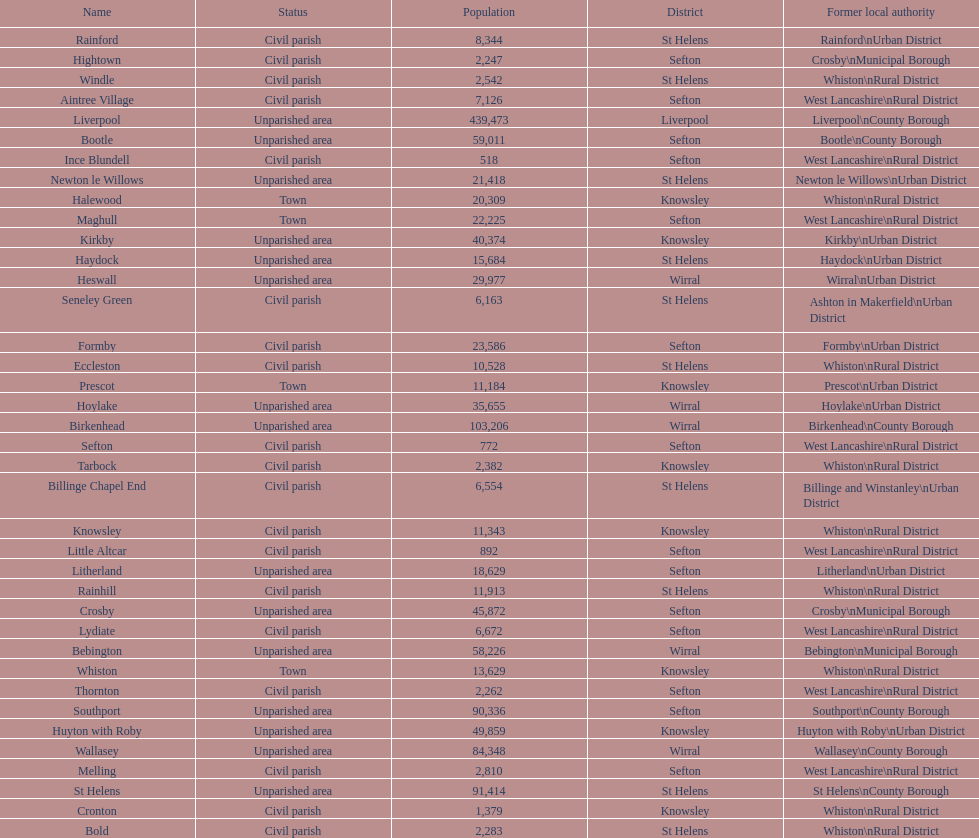Which area has the least number of residents? Ince Blundell. Would you be able to parse every entry in this table? {'header': ['Name', 'Status', 'Population', 'District', 'Former local authority'], 'rows': [['Rainford', 'Civil parish', '8,344', 'St Helens', 'Rainford\\nUrban District'], ['Hightown', 'Civil parish', '2,247', 'Sefton', 'Crosby\\nMunicipal Borough'], ['Windle', 'Civil parish', '2,542', 'St Helens', 'Whiston\\nRural District'], ['Aintree Village', 'Civil parish', '7,126', 'Sefton', 'West Lancashire\\nRural District'], ['Liverpool', 'Unparished area', '439,473', 'Liverpool', 'Liverpool\\nCounty Borough'], ['Bootle', 'Unparished area', '59,011', 'Sefton', 'Bootle\\nCounty Borough'], ['Ince Blundell', 'Civil parish', '518', 'Sefton', 'West Lancashire\\nRural District'], ['Newton le Willows', 'Unparished area', '21,418', 'St Helens', 'Newton le Willows\\nUrban District'], ['Halewood', 'Town', '20,309', 'Knowsley', 'Whiston\\nRural District'], ['Maghull', 'Town', '22,225', 'Sefton', 'West Lancashire\\nRural District'], ['Kirkby', 'Unparished area', '40,374', 'Knowsley', 'Kirkby\\nUrban District'], ['Haydock', 'Unparished area', '15,684', 'St Helens', 'Haydock\\nUrban District'], ['Heswall', 'Unparished area', '29,977', 'Wirral', 'Wirral\\nUrban District'], ['Seneley Green', 'Civil parish', '6,163', 'St Helens', 'Ashton in Makerfield\\nUrban District'], ['Formby', 'Civil parish', '23,586', 'Sefton', 'Formby\\nUrban District'], ['Eccleston', 'Civil parish', '10,528', 'St Helens', 'Whiston\\nRural District'], ['Prescot', 'Town', '11,184', 'Knowsley', 'Prescot\\nUrban District'], ['Hoylake', 'Unparished area', '35,655', 'Wirral', 'Hoylake\\nUrban District'], ['Birkenhead', 'Unparished area', '103,206', 'Wirral', 'Birkenhead\\nCounty Borough'], ['Sefton', 'Civil parish', '772', 'Sefton', 'West Lancashire\\nRural District'], ['Tarbock', 'Civil parish', '2,382', 'Knowsley', 'Whiston\\nRural District'], ['Billinge Chapel End', 'Civil parish', '6,554', 'St Helens', 'Billinge and Winstanley\\nUrban District'], ['Knowsley', 'Civil parish', '11,343', 'Knowsley', 'Whiston\\nRural District'], ['Little Altcar', 'Civil parish', '892', 'Sefton', 'West Lancashire\\nRural District'], ['Litherland', 'Unparished area', '18,629', 'Sefton', 'Litherland\\nUrban District'], ['Rainhill', 'Civil parish', '11,913', 'St Helens', 'Whiston\\nRural District'], ['Crosby', 'Unparished area', '45,872', 'Sefton', 'Crosby\\nMunicipal Borough'], ['Lydiate', 'Civil parish', '6,672', 'Sefton', 'West Lancashire\\nRural District'], ['Bebington', 'Unparished area', '58,226', 'Wirral', 'Bebington\\nMunicipal Borough'], ['Whiston', 'Town', '13,629', 'Knowsley', 'Whiston\\nRural District'], ['Thornton', 'Civil parish', '2,262', 'Sefton', 'West Lancashire\\nRural District'], ['Southport', 'Unparished area', '90,336', 'Sefton', 'Southport\\nCounty Borough'], ['Huyton with Roby', 'Unparished area', '49,859', 'Knowsley', 'Huyton with Roby\\nUrban District'], ['Wallasey', 'Unparished area', '84,348', 'Wirral', 'Wallasey\\nCounty Borough'], ['Melling', 'Civil parish', '2,810', 'Sefton', 'West Lancashire\\nRural District'], ['St Helens', 'Unparished area', '91,414', 'St Helens', 'St Helens\\nCounty Borough'], ['Cronton', 'Civil parish', '1,379', 'Knowsley', 'Whiston\\nRural District'], ['Bold', 'Civil parish', '2,283', 'St Helens', 'Whiston\\nRural District']]} 